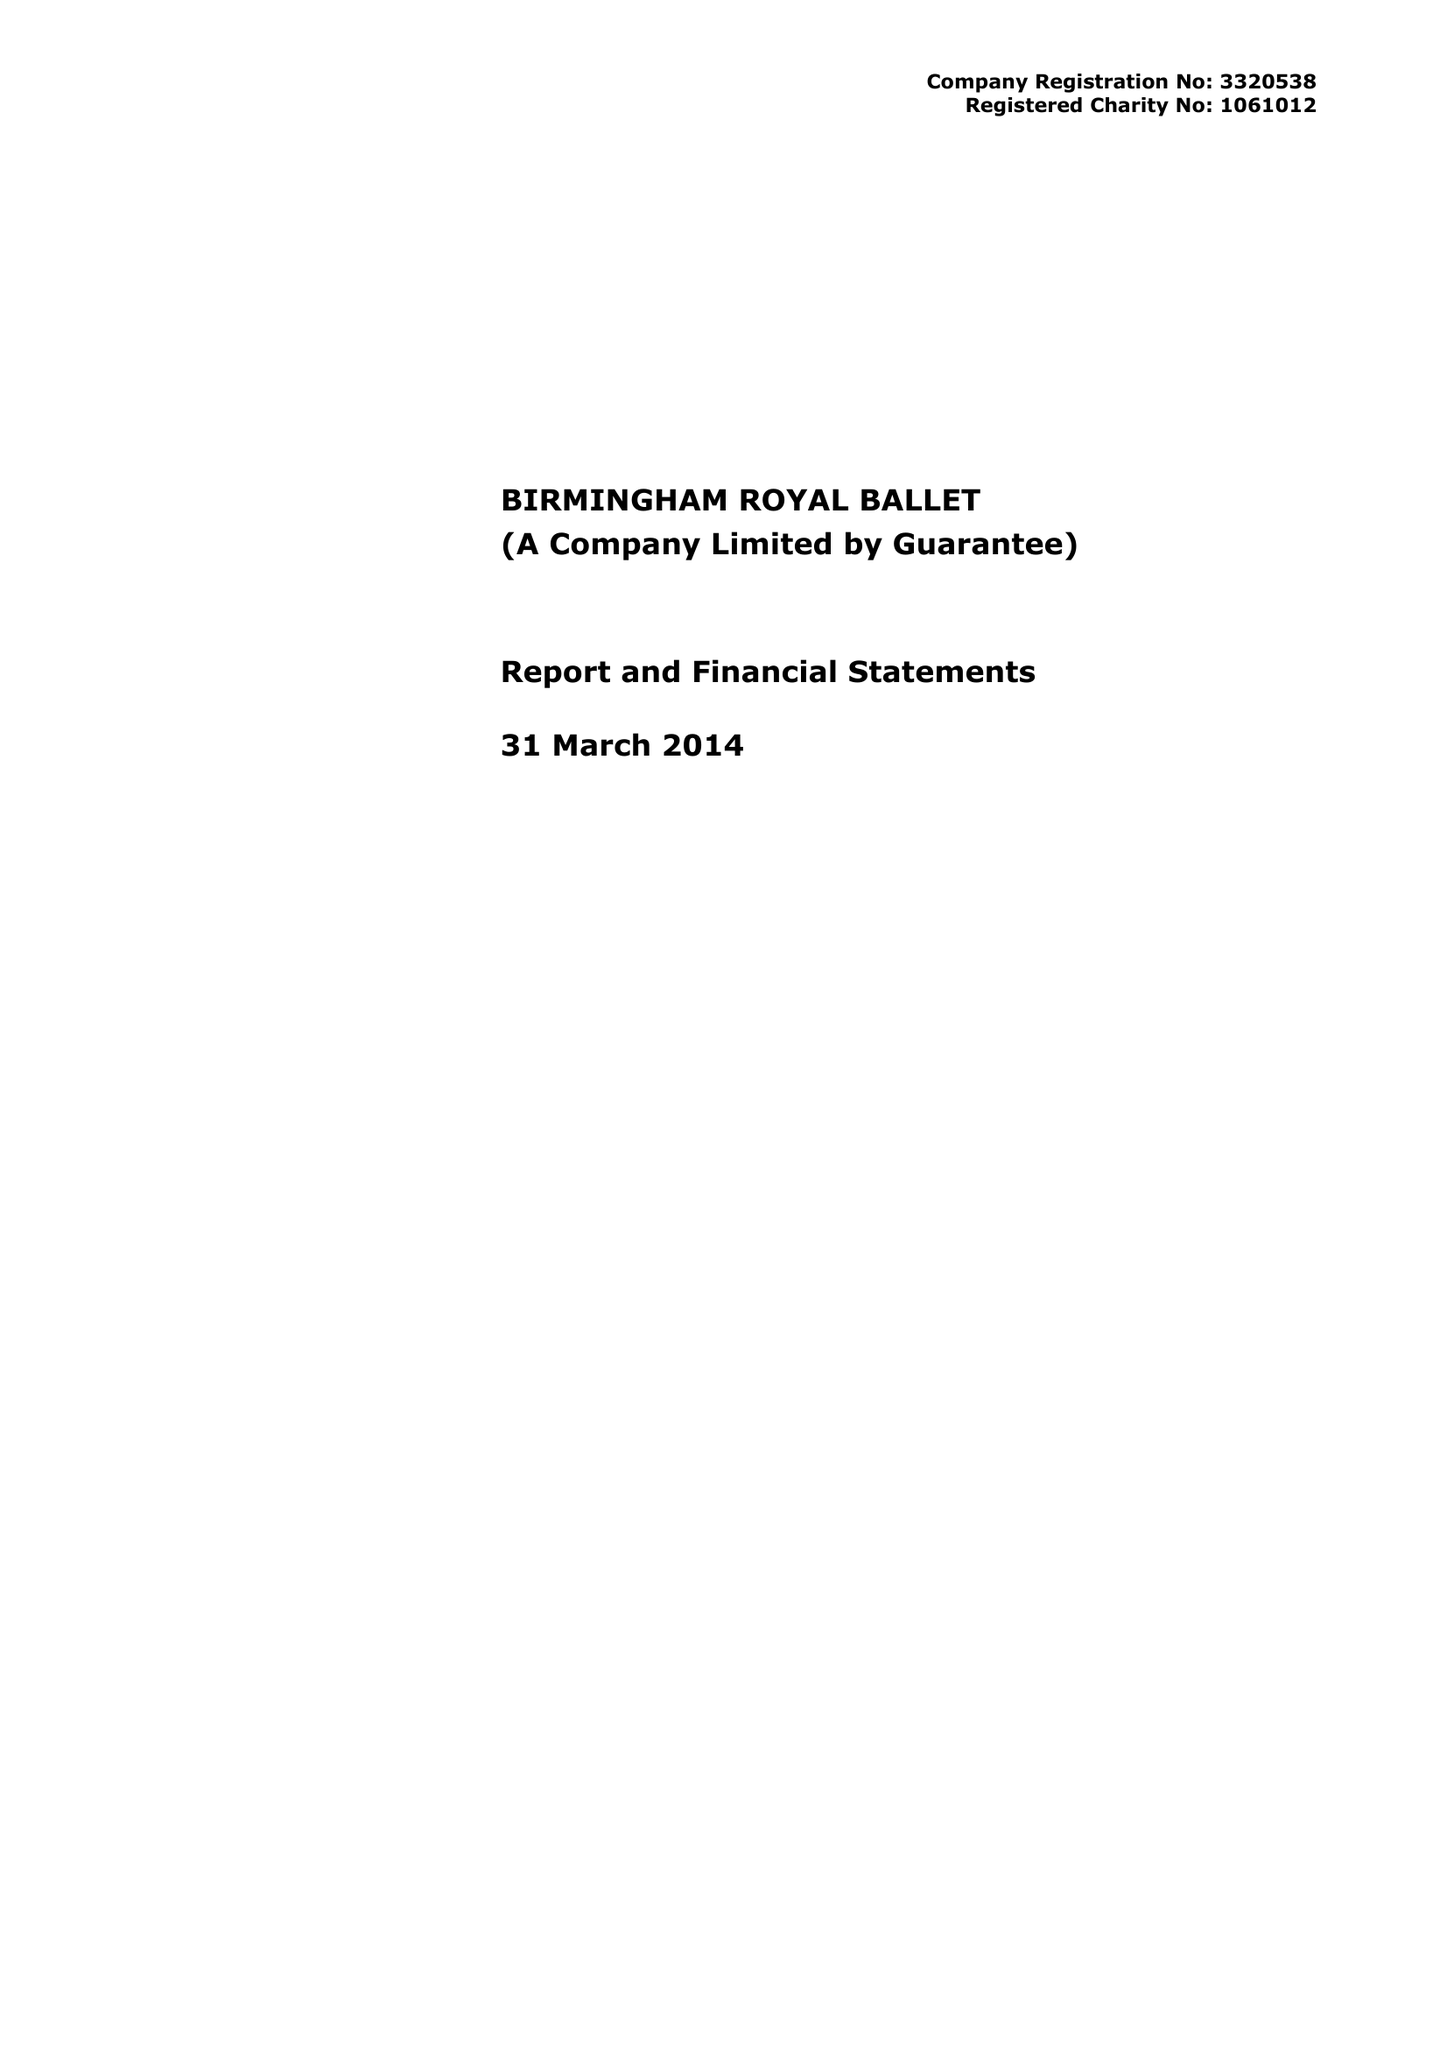What is the value for the spending_annually_in_british_pounds?
Answer the question using a single word or phrase. 12935140.00 